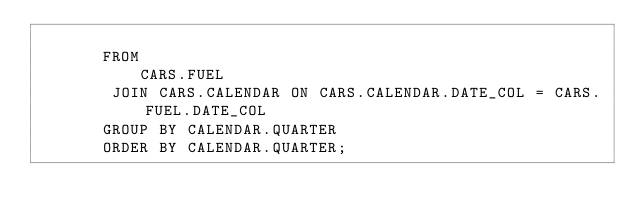<code> <loc_0><loc_0><loc_500><loc_500><_SQL_>
       FROM
           CARS.FUEL
        JOIN CARS.CALENDAR ON CARS.CALENDAR.DATE_COL = CARS.FUEL.DATE_COL
       GROUP BY CALENDAR.QUARTER
       ORDER BY CALENDAR.QUARTER;
</code> 